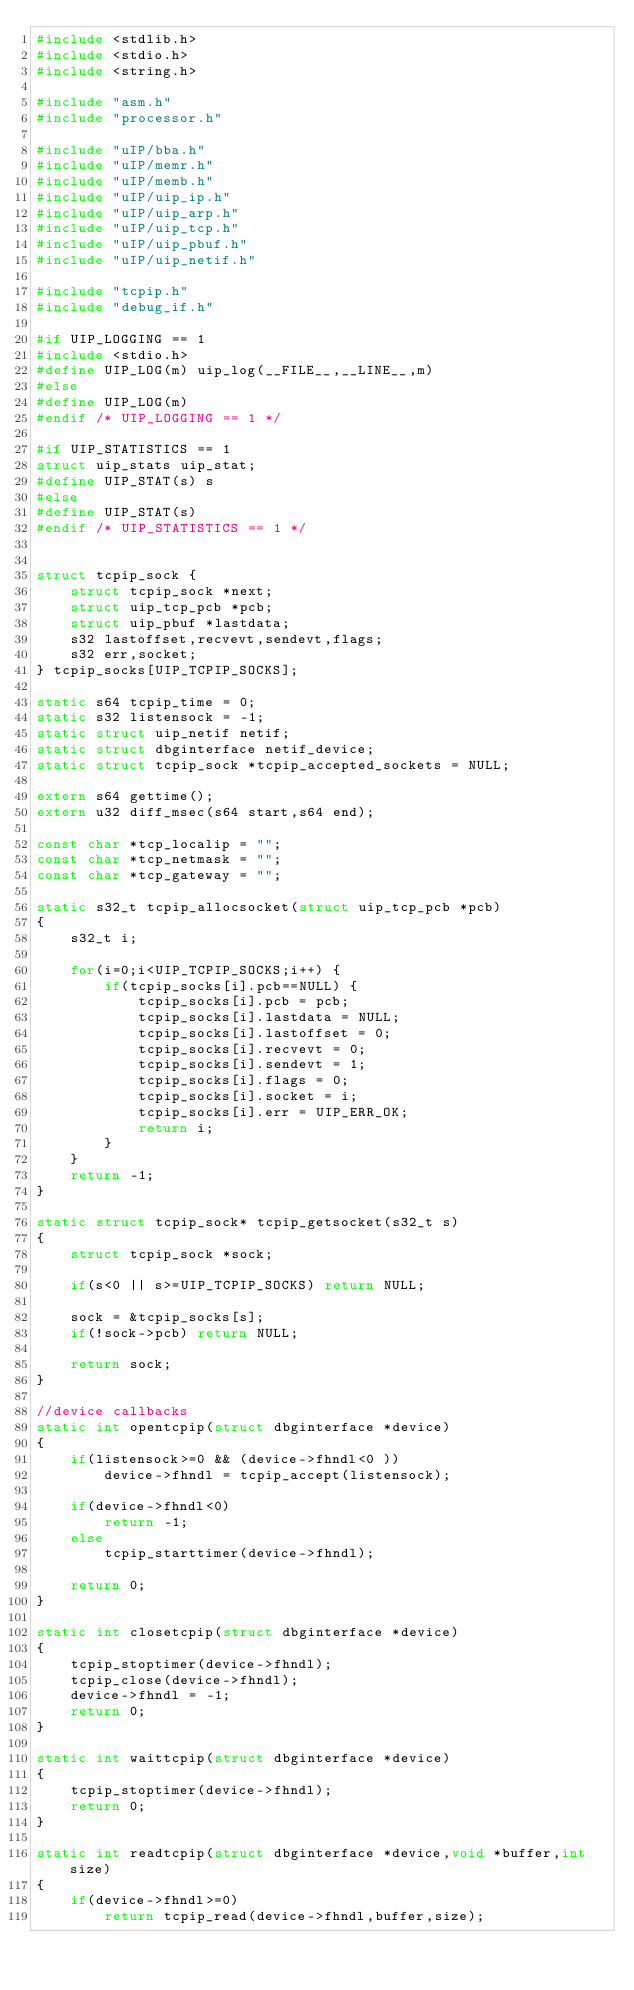<code> <loc_0><loc_0><loc_500><loc_500><_C_>#include <stdlib.h>
#include <stdio.h>
#include <string.h>

#include "asm.h"
#include "processor.h"

#include "uIP/bba.h"
#include "uIP/memr.h"
#include "uIP/memb.h"
#include "uIP/uip_ip.h"
#include "uIP/uip_arp.h"
#include "uIP/uip_tcp.h"
#include "uIP/uip_pbuf.h"
#include "uIP/uip_netif.h"

#include "tcpip.h"
#include "debug_if.h"

#if UIP_LOGGING == 1
#include <stdio.h>
#define UIP_LOG(m) uip_log(__FILE__,__LINE__,m)
#else
#define UIP_LOG(m)
#endif /* UIP_LOGGING == 1 */

#if UIP_STATISTICS == 1
struct uip_stats uip_stat;
#define UIP_STAT(s) s
#else
#define UIP_STAT(s)
#endif /* UIP_STATISTICS == 1 */


struct tcpip_sock {
	struct tcpip_sock *next;
	struct uip_tcp_pcb *pcb;
	struct uip_pbuf *lastdata;
	s32 lastoffset,recvevt,sendevt,flags;
	s32 err,socket;
} tcpip_socks[UIP_TCPIP_SOCKS];

static s64 tcpip_time = 0;
static s32 listensock = -1;
static struct uip_netif netif;
static struct dbginterface netif_device;
static struct tcpip_sock *tcpip_accepted_sockets = NULL;

extern s64 gettime();
extern u32 diff_msec(s64 start,s64 end);

const char *tcp_localip = "";
const char *tcp_netmask = "";
const char *tcp_gateway = "";

static s32_t tcpip_allocsocket(struct uip_tcp_pcb *pcb)
{
	s32_t i;

	for(i=0;i<UIP_TCPIP_SOCKS;i++) {
		if(tcpip_socks[i].pcb==NULL) {
			tcpip_socks[i].pcb = pcb;
			tcpip_socks[i].lastdata = NULL;
			tcpip_socks[i].lastoffset = 0;
			tcpip_socks[i].recvevt = 0;
			tcpip_socks[i].sendevt = 1;
			tcpip_socks[i].flags = 0;
			tcpip_socks[i].socket = i;
			tcpip_socks[i].err = UIP_ERR_OK;
			return i;
		}
	}
	return -1;
}

static struct tcpip_sock* tcpip_getsocket(s32_t s)
{
	struct tcpip_sock *sock;

	if(s<0 || s>=UIP_TCPIP_SOCKS) return NULL;

	sock = &tcpip_socks[s];
	if(!sock->pcb) return NULL;

	return sock;
}

//device callbacks
static int opentcpip(struct dbginterface *device)
{
	if(listensock>=0 && (device->fhndl<0 ))
		device->fhndl = tcpip_accept(listensock);

	if(device->fhndl<0) 
		return -1;
	else 
		tcpip_starttimer(device->fhndl);

	return 0;
}

static int closetcpip(struct dbginterface *device)
{
	tcpip_stoptimer(device->fhndl);
	tcpip_close(device->fhndl);
	device->fhndl = -1;
	return 0;
}

static int waittcpip(struct dbginterface *device)
{
	tcpip_stoptimer(device->fhndl);
	return 0;
}

static int readtcpip(struct dbginterface *device,void *buffer,int size)
{
	if(device->fhndl>=0)
		return tcpip_read(device->fhndl,buffer,size);
</code> 